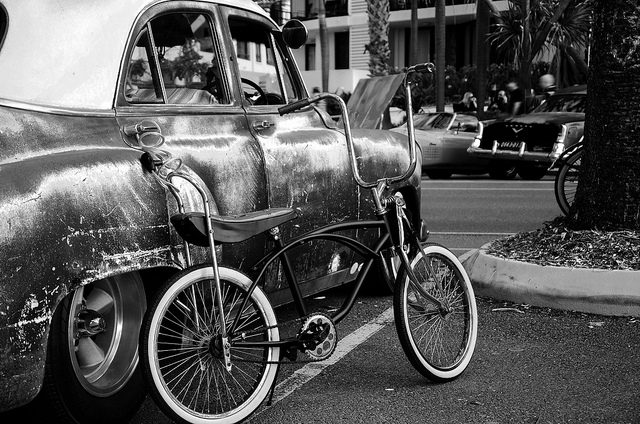What kind of mood does this black and white image evoke? The black and white tones contribute to a nostalgic ambiance, accentuating the contrast between light and shadow while highlighting textures, and it imbues the scene with a timeless quality. 